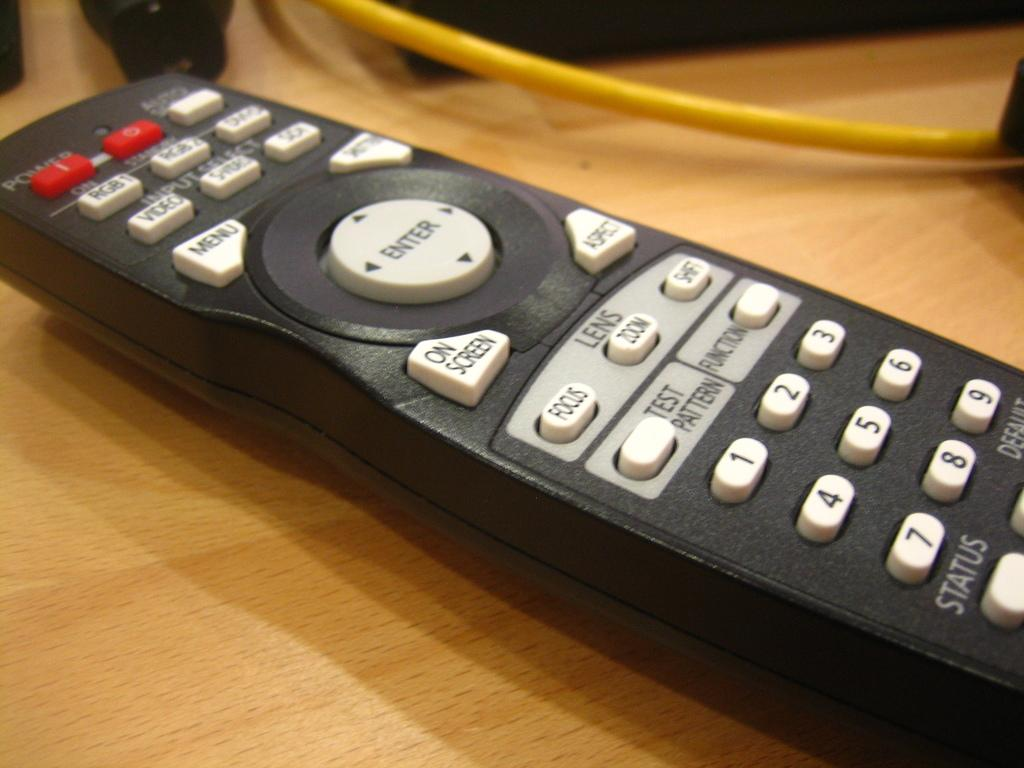<image>
Give a short and clear explanation of the subsequent image. A TV remote has buttons with the numbers 1 through 9 and a menu button. 